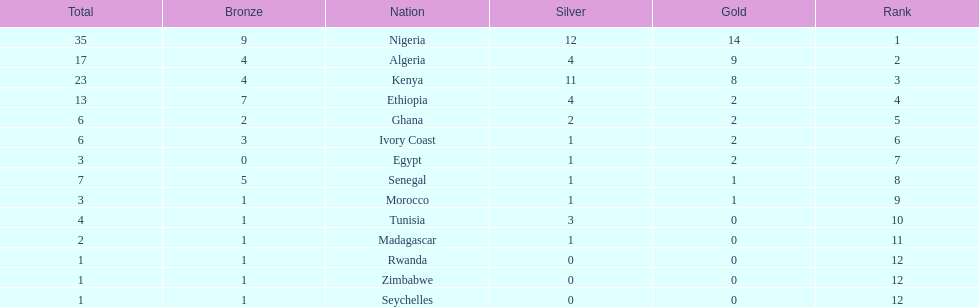Give me the full table as a dictionary. {'header': ['Total', 'Bronze', 'Nation', 'Silver', 'Gold', 'Rank'], 'rows': [['35', '9', 'Nigeria', '12', '14', '1'], ['17', '4', 'Algeria', '4', '9', '2'], ['23', '4', 'Kenya', '11', '8', '3'], ['13', '7', 'Ethiopia', '4', '2', '4'], ['6', '2', 'Ghana', '2', '2', '5'], ['6', '3', 'Ivory Coast', '1', '2', '6'], ['3', '0', 'Egypt', '1', '2', '7'], ['7', '5', 'Senegal', '1', '1', '8'], ['3', '1', 'Morocco', '1', '1', '9'], ['4', '1', 'Tunisia', '3', '0', '10'], ['2', '1', 'Madagascar', '1', '0', '11'], ['1', '1', 'Rwanda', '0', '0', '12'], ['1', '1', 'Zimbabwe', '0', '0', '12'], ['1', '1', 'Seychelles', '0', '0', '12']]} Which nations have won only one medal? Rwanda, Zimbabwe, Seychelles. 